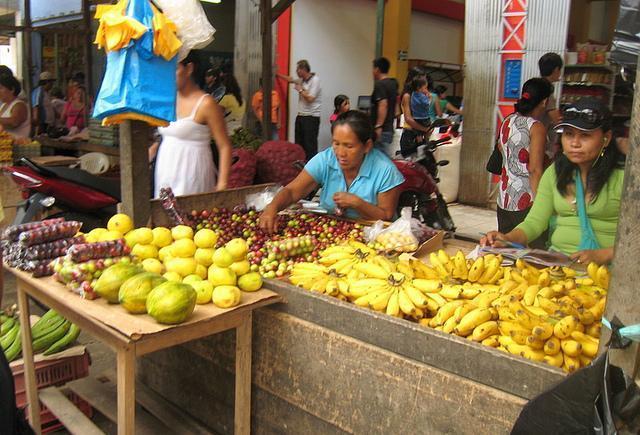How many bananas are there?
Give a very brief answer. 2. How many people are in the photo?
Give a very brief answer. 5. How many baby giraffes are in this picture?
Give a very brief answer. 0. 